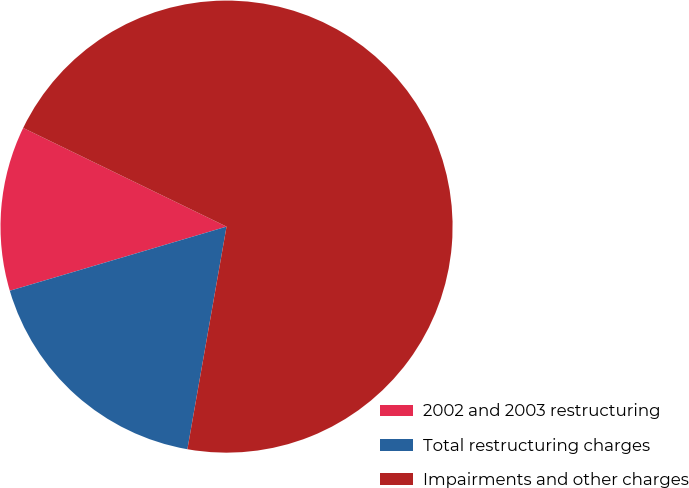<chart> <loc_0><loc_0><loc_500><loc_500><pie_chart><fcel>2002 and 2003 restructuring<fcel>Total restructuring charges<fcel>Impairments and other charges<nl><fcel>11.77%<fcel>17.65%<fcel>70.58%<nl></chart> 